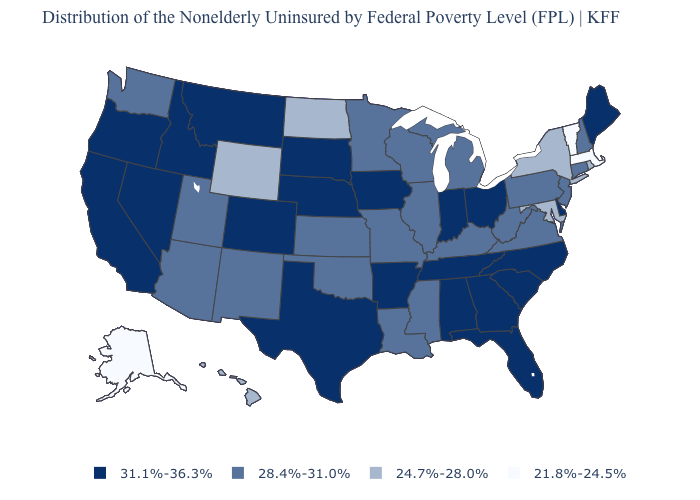Name the states that have a value in the range 31.1%-36.3%?
Answer briefly. Alabama, Arkansas, California, Colorado, Delaware, Florida, Georgia, Idaho, Indiana, Iowa, Maine, Montana, Nebraska, Nevada, North Carolina, Ohio, Oregon, South Carolina, South Dakota, Tennessee, Texas. Name the states that have a value in the range 24.7%-28.0%?
Give a very brief answer. Hawaii, Maryland, New York, North Dakota, Rhode Island, Wyoming. Among the states that border Idaho , which have the lowest value?
Concise answer only. Wyoming. Name the states that have a value in the range 24.7%-28.0%?
Keep it brief. Hawaii, Maryland, New York, North Dakota, Rhode Island, Wyoming. Name the states that have a value in the range 21.8%-24.5%?
Be succinct. Alaska, Massachusetts, Vermont. Name the states that have a value in the range 28.4%-31.0%?
Answer briefly. Arizona, Connecticut, Illinois, Kansas, Kentucky, Louisiana, Michigan, Minnesota, Mississippi, Missouri, New Hampshire, New Jersey, New Mexico, Oklahoma, Pennsylvania, Utah, Virginia, Washington, West Virginia, Wisconsin. Which states have the lowest value in the South?
Be succinct. Maryland. Does New York have a higher value than Ohio?
Quick response, please. No. Among the states that border Vermont , which have the lowest value?
Be succinct. Massachusetts. Does Alaska have the lowest value in the USA?
Answer briefly. Yes. What is the value of Hawaii?
Give a very brief answer. 24.7%-28.0%. Name the states that have a value in the range 28.4%-31.0%?
Write a very short answer. Arizona, Connecticut, Illinois, Kansas, Kentucky, Louisiana, Michigan, Minnesota, Mississippi, Missouri, New Hampshire, New Jersey, New Mexico, Oklahoma, Pennsylvania, Utah, Virginia, Washington, West Virginia, Wisconsin. What is the value of Wisconsin?
Quick response, please. 28.4%-31.0%. What is the value of Colorado?
Short answer required. 31.1%-36.3%. Name the states that have a value in the range 28.4%-31.0%?
Give a very brief answer. Arizona, Connecticut, Illinois, Kansas, Kentucky, Louisiana, Michigan, Minnesota, Mississippi, Missouri, New Hampshire, New Jersey, New Mexico, Oklahoma, Pennsylvania, Utah, Virginia, Washington, West Virginia, Wisconsin. 